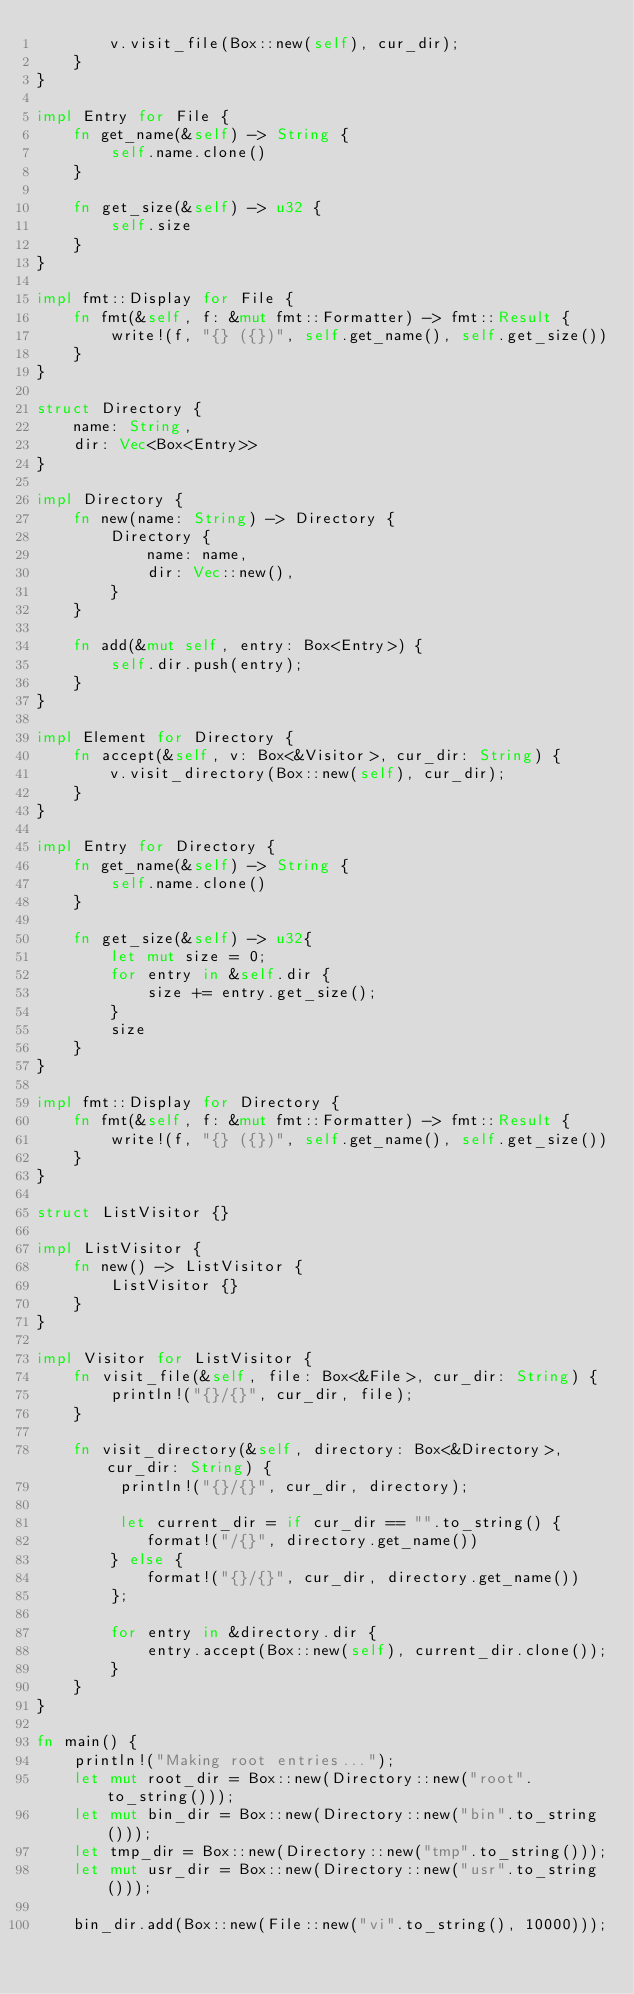<code> <loc_0><loc_0><loc_500><loc_500><_Rust_>        v.visit_file(Box::new(self), cur_dir);
    }
}

impl Entry for File {
    fn get_name(&self) -> String {
        self.name.clone()
    }

    fn get_size(&self) -> u32 {
        self.size
    }
}

impl fmt::Display for File {
    fn fmt(&self, f: &mut fmt::Formatter) -> fmt::Result {
        write!(f, "{} ({})", self.get_name(), self.get_size())
    }
}

struct Directory {
    name: String,
    dir: Vec<Box<Entry>>
}

impl Directory {
    fn new(name: String) -> Directory {
        Directory {
            name: name,
            dir: Vec::new(),
        }
    }

    fn add(&mut self, entry: Box<Entry>) {
        self.dir.push(entry);
    }
}

impl Element for Directory {
    fn accept(&self, v: Box<&Visitor>, cur_dir: String) {
        v.visit_directory(Box::new(self), cur_dir);
    }
}

impl Entry for Directory {
    fn get_name(&self) -> String {
        self.name.clone()
    }

    fn get_size(&self) -> u32{
        let mut size = 0;
        for entry in &self.dir {
            size += entry.get_size();
        }
        size
    }
}

impl fmt::Display for Directory {
    fn fmt(&self, f: &mut fmt::Formatter) -> fmt::Result {
        write!(f, "{} ({})", self.get_name(), self.get_size())
    }
}

struct ListVisitor {}

impl ListVisitor {
    fn new() -> ListVisitor {
        ListVisitor {}
    }
}

impl Visitor for ListVisitor {
    fn visit_file(&self, file: Box<&File>, cur_dir: String) {
        println!("{}/{}", cur_dir, file);
    }

    fn visit_directory(&self, directory: Box<&Directory>, cur_dir: String) {
         println!("{}/{}", cur_dir, directory);
        
         let current_dir = if cur_dir == "".to_string() {
            format!("/{}", directory.get_name())
        } else {
            format!("{}/{}", cur_dir, directory.get_name())
        };

        for entry in &directory.dir {
            entry.accept(Box::new(self), current_dir.clone());
        }
    }
}

fn main() {
    println!("Making root entries...");
    let mut root_dir = Box::new(Directory::new("root".to_string()));
    let mut bin_dir = Box::new(Directory::new("bin".to_string()));
    let tmp_dir = Box::new(Directory::new("tmp".to_string()));
    let mut usr_dir = Box::new(Directory::new("usr".to_string()));

    bin_dir.add(Box::new(File::new("vi".to_string(), 10000)));</code> 